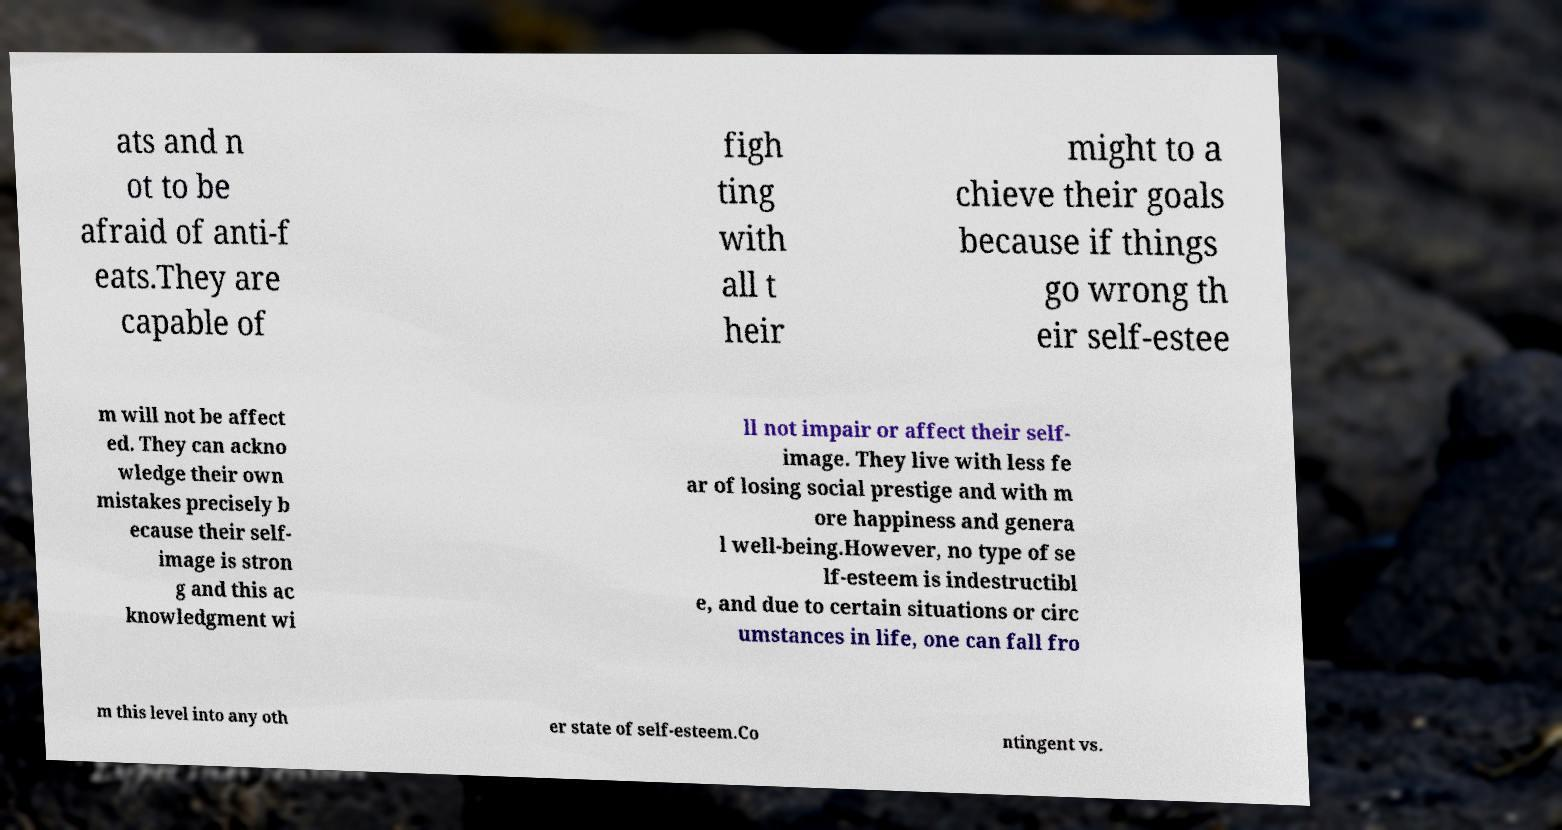Can you read and provide the text displayed in the image?This photo seems to have some interesting text. Can you extract and type it out for me? ats and n ot to be afraid of anti-f eats.They are capable of figh ting with all t heir might to a chieve their goals because if things go wrong th eir self-estee m will not be affect ed. They can ackno wledge their own mistakes precisely b ecause their self- image is stron g and this ac knowledgment wi ll not impair or affect their self- image. They live with less fe ar of losing social prestige and with m ore happiness and genera l well-being.However, no type of se lf-esteem is indestructibl e, and due to certain situations or circ umstances in life, one can fall fro m this level into any oth er state of self-esteem.Co ntingent vs. 